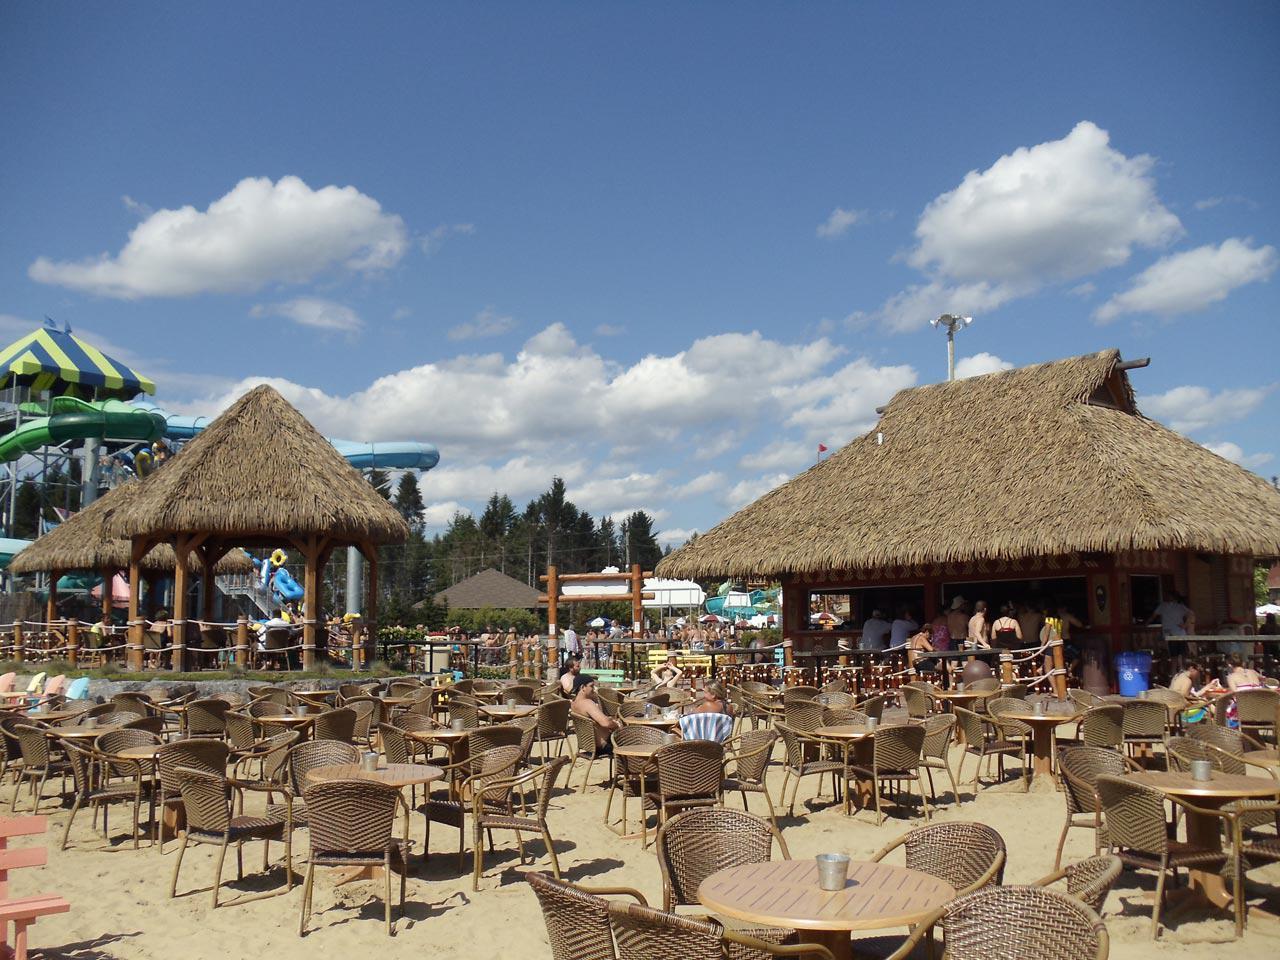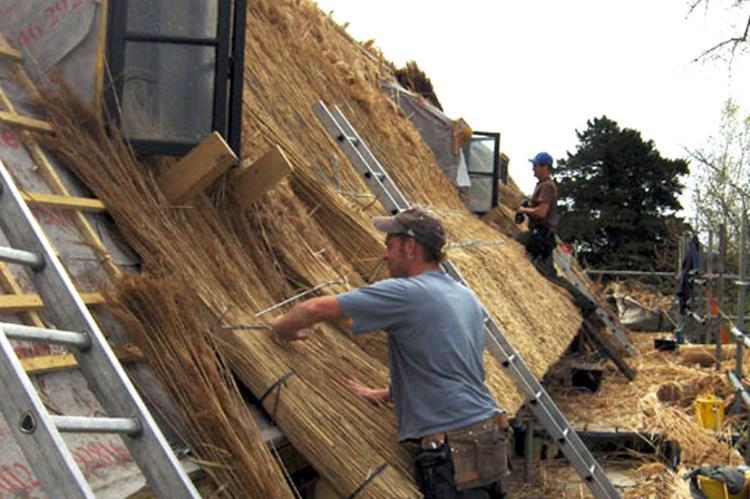The first image is the image on the left, the second image is the image on the right. Examine the images to the left and right. Is the description "The left image shows a man installing a thatch roof, and the right image shows a ladder propped on an unfinished roof piled with thatch." accurate? Answer yes or no. No. The first image is the image on the left, the second image is the image on the right. Analyze the images presented: Is the assertion "There are windows in the right image." valid? Answer yes or no. Yes. 